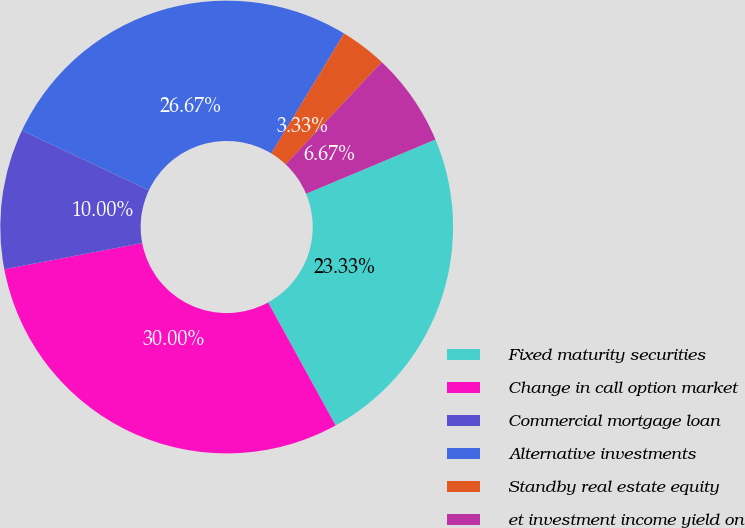<chart> <loc_0><loc_0><loc_500><loc_500><pie_chart><fcel>Fixed maturity securities<fcel>Change in call option market<fcel>Commercial mortgage loan<fcel>Alternative investments<fcel>Standby real estate equity<fcel>et investment income yield on<nl><fcel>23.33%<fcel>30.0%<fcel>10.0%<fcel>26.67%<fcel>3.33%<fcel>6.67%<nl></chart> 